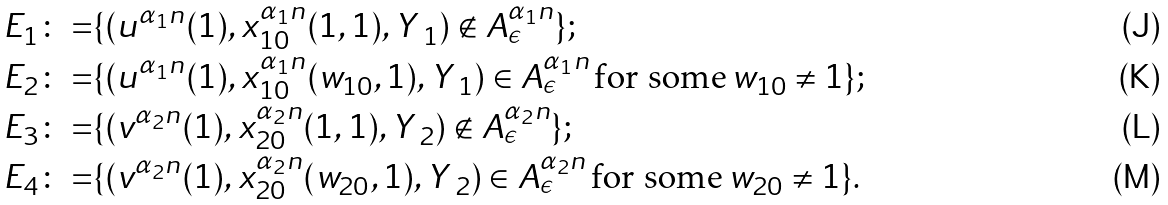<formula> <loc_0><loc_0><loc_500><loc_500>E _ { 1 } \colon = & \{ ( u ^ { \alpha _ { 1 } n } ( 1 ) , x _ { 1 0 } ^ { \alpha _ { 1 } n } ( 1 , 1 ) , Y \, _ { 1 } ) \not \in A _ { \epsilon } ^ { \alpha _ { 1 } n } \} ; \\ E _ { 2 } \colon = & \{ ( u ^ { \alpha _ { 1 } n } ( 1 ) , x _ { 1 0 } ^ { \alpha _ { 1 } n } ( w _ { 1 0 } , 1 ) , Y \, _ { 1 } ) \in A _ { \epsilon } ^ { \alpha _ { 1 } n } \, \text {for some} \, w _ { 1 0 } \neq 1 \} ; \\ E _ { 3 } \colon = & \{ ( v ^ { \alpha _ { 2 } n } ( 1 ) , x _ { 2 0 } ^ { \alpha _ { 2 } n } ( 1 , 1 ) , Y \, _ { 2 } ) \not \in A _ { \epsilon } ^ { \alpha _ { 2 } n } \} ; \\ E _ { 4 } \colon = & \{ ( v ^ { \alpha _ { 2 } n } ( 1 ) , x _ { 2 0 } ^ { \alpha _ { 2 } n } ( w _ { 2 0 } , 1 ) , Y \, _ { 2 } ) \in A _ { \epsilon } ^ { \alpha _ { 2 } n } \, \text {for some} \, w _ { 2 0 } \neq 1 \} .</formula> 